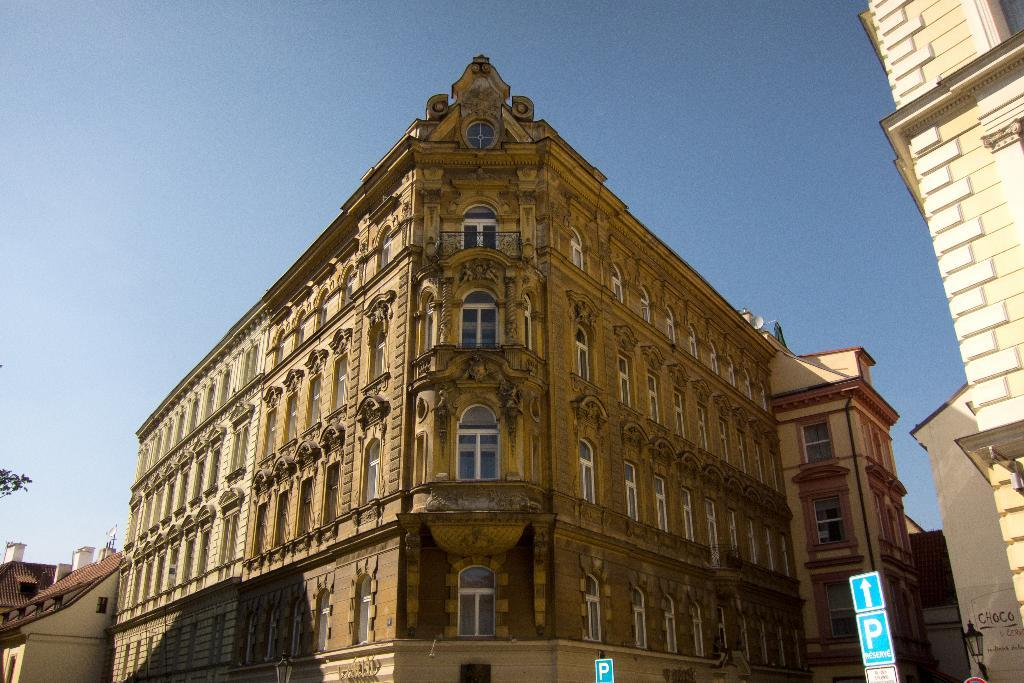What type of structures are present in the image? There are buildings with windows in the image. What can be seen at the bottom of the image? There are sign boards at the bottom of the image. What is illuminating the scene in the image? There is a light visible in the image. What part of the natural environment is visible in the image? The sky is visible in the image. What type of pump is visible in the image? There is no pump present in the image. What is causing the throat irritation in the image? There is no mention of throat irritation or any related subject in the image. 